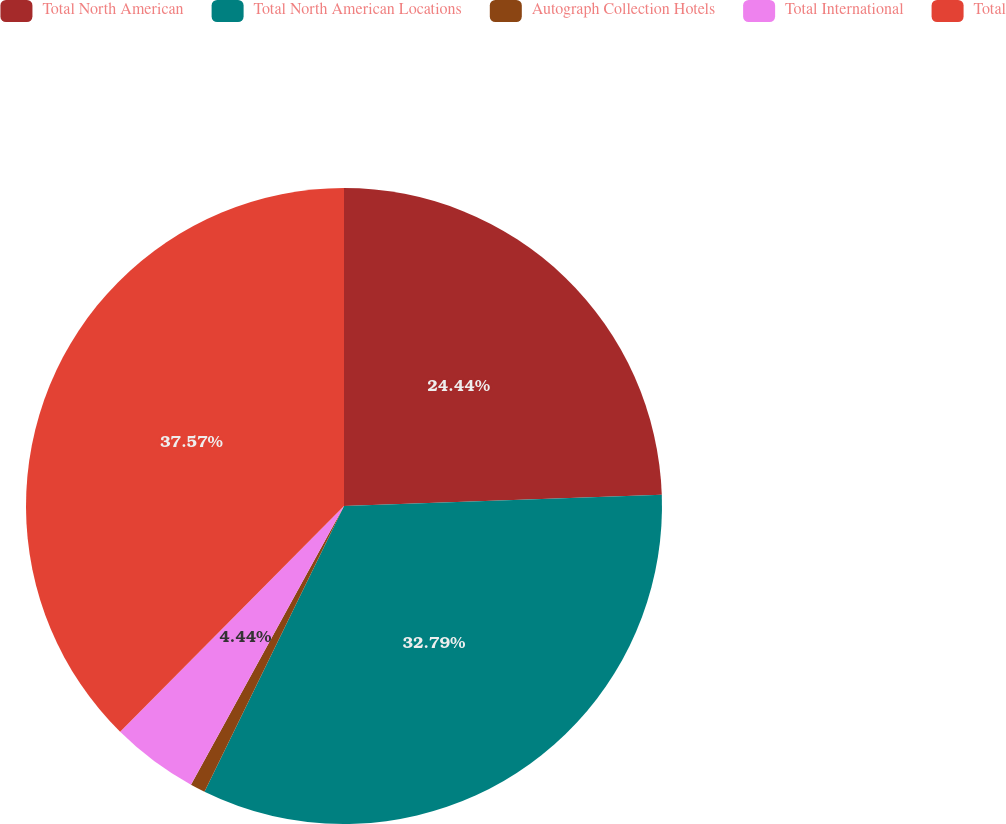Convert chart. <chart><loc_0><loc_0><loc_500><loc_500><pie_chart><fcel>Total North American<fcel>Total North American Locations<fcel>Autograph Collection Hotels<fcel>Total International<fcel>Total<nl><fcel>24.44%<fcel>32.79%<fcel>0.76%<fcel>4.44%<fcel>37.57%<nl></chart> 